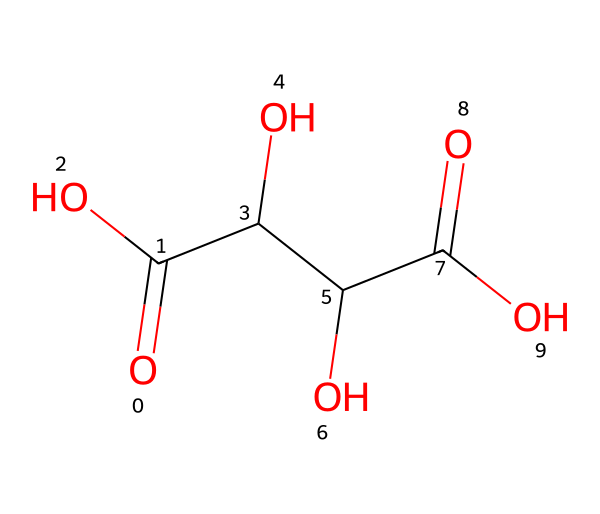What is the name of this compound? The SMILES representation provided corresponds to tartaric acid, a compound commonly found in wine and important for its acidity and taste.
Answer: tartaric acid How many carbon atoms are present in the structure? By analyzing the SMILES structure, we can identify four carbon atoms (C) from the formula, each connected to different functional groups.
Answer: four What functional groups are present in tartaric acid? The structure shows two carboxylic acid groups (-COOH) and three hydroxyl groups (-OH), indicating the presence of both acidic and alcohol functional groups.
Answer: carboxylic acid and hydroxyl groups What is the total number of hydrogen atoms in tartaric acid? The analysis of the structure shows that tartaric acid has six hydrogen atoms, derived from the various functional groups attached to the carbon skeleton.
Answer: six Which type of isomerism is exhibited by tartaric acid? Tartaric acid can exist as enantiomers due to the presence of two chiral centers (the two carbon atoms with hydroxyl groups), making it an example of stereoisomerism.
Answer: stereoisomerism How does the presence of hydroxyl groups affect the solubility of tartaric acid? The presence of multiple hydroxyl groups in tartaric acid increases its polarity, allowing it to form hydrogen bonds with water, thus making it soluble.
Answer: increases solubility 